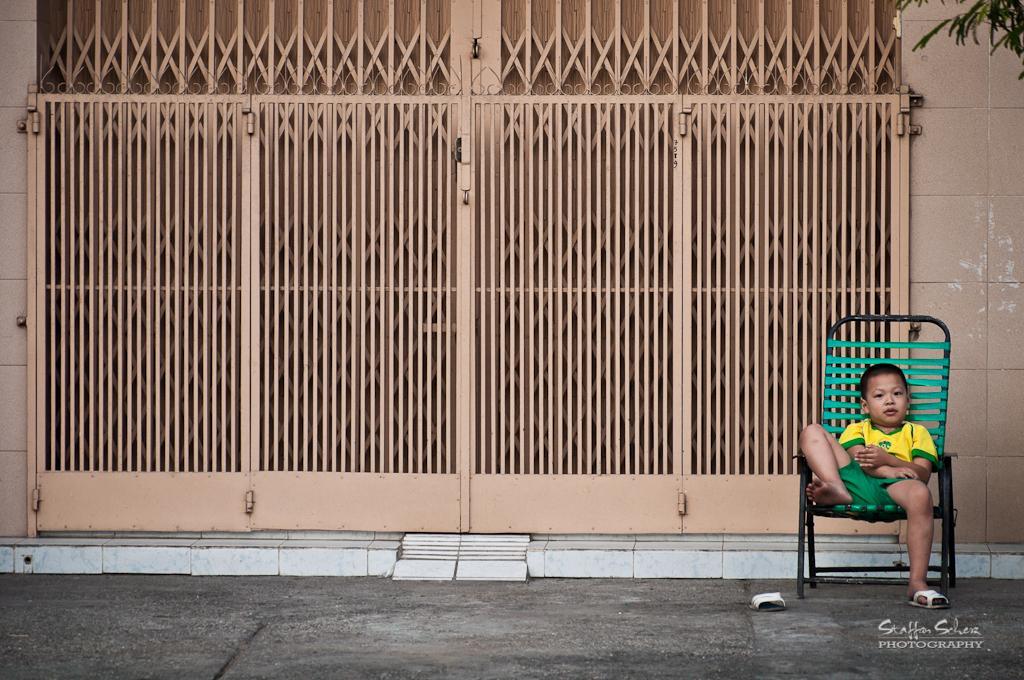Please provide a concise description of this image. This picture is taken outside the building where the boy is sitting on a chair at the left side. In the center there is a gate which is in the form of grill. At the right side there is a wall of the building and some leaves. 